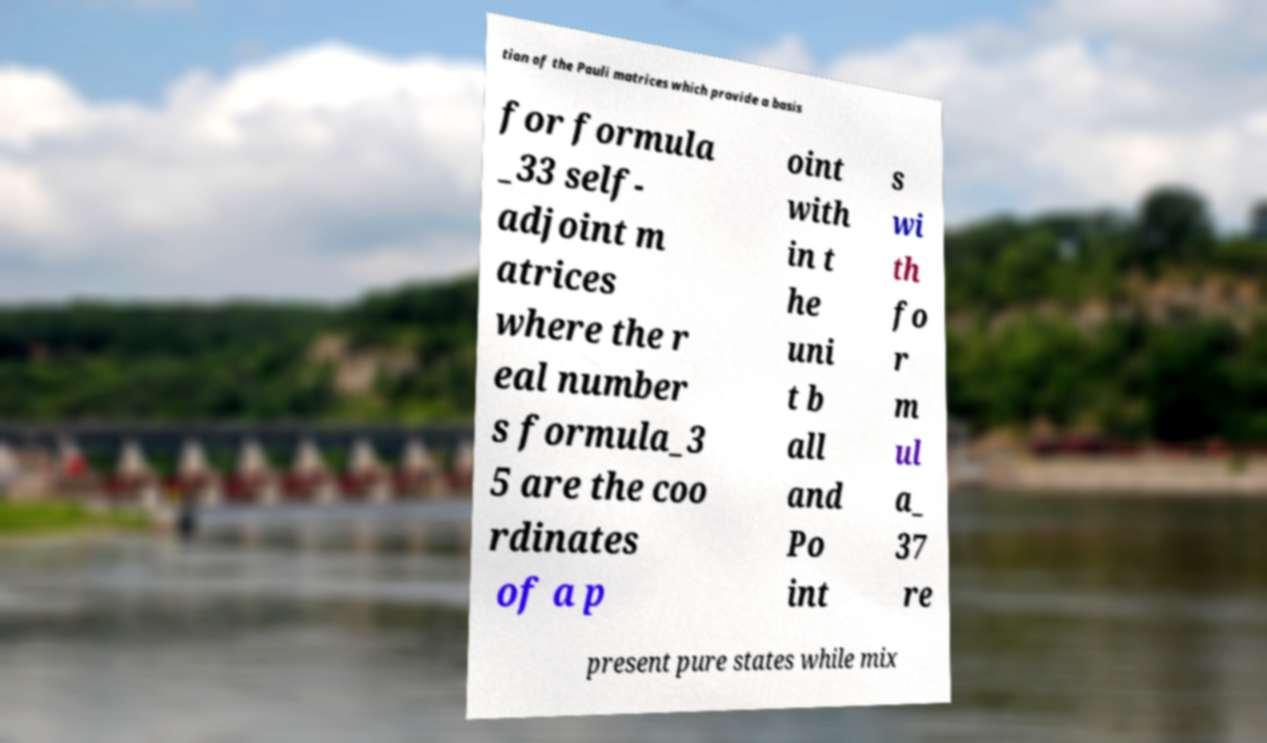Please read and relay the text visible in this image. What does it say? tion of the Pauli matrices which provide a basis for formula _33 self- adjoint m atrices where the r eal number s formula_3 5 are the coo rdinates of a p oint with in t he uni t b all and Po int s wi th fo r m ul a_ 37 re present pure states while mix 